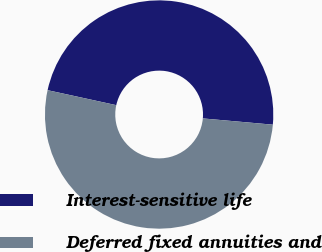<chart> <loc_0><loc_0><loc_500><loc_500><pie_chart><fcel>Interest-sensitive life<fcel>Deferred fixed annuities and<nl><fcel>48.0%<fcel>52.0%<nl></chart> 